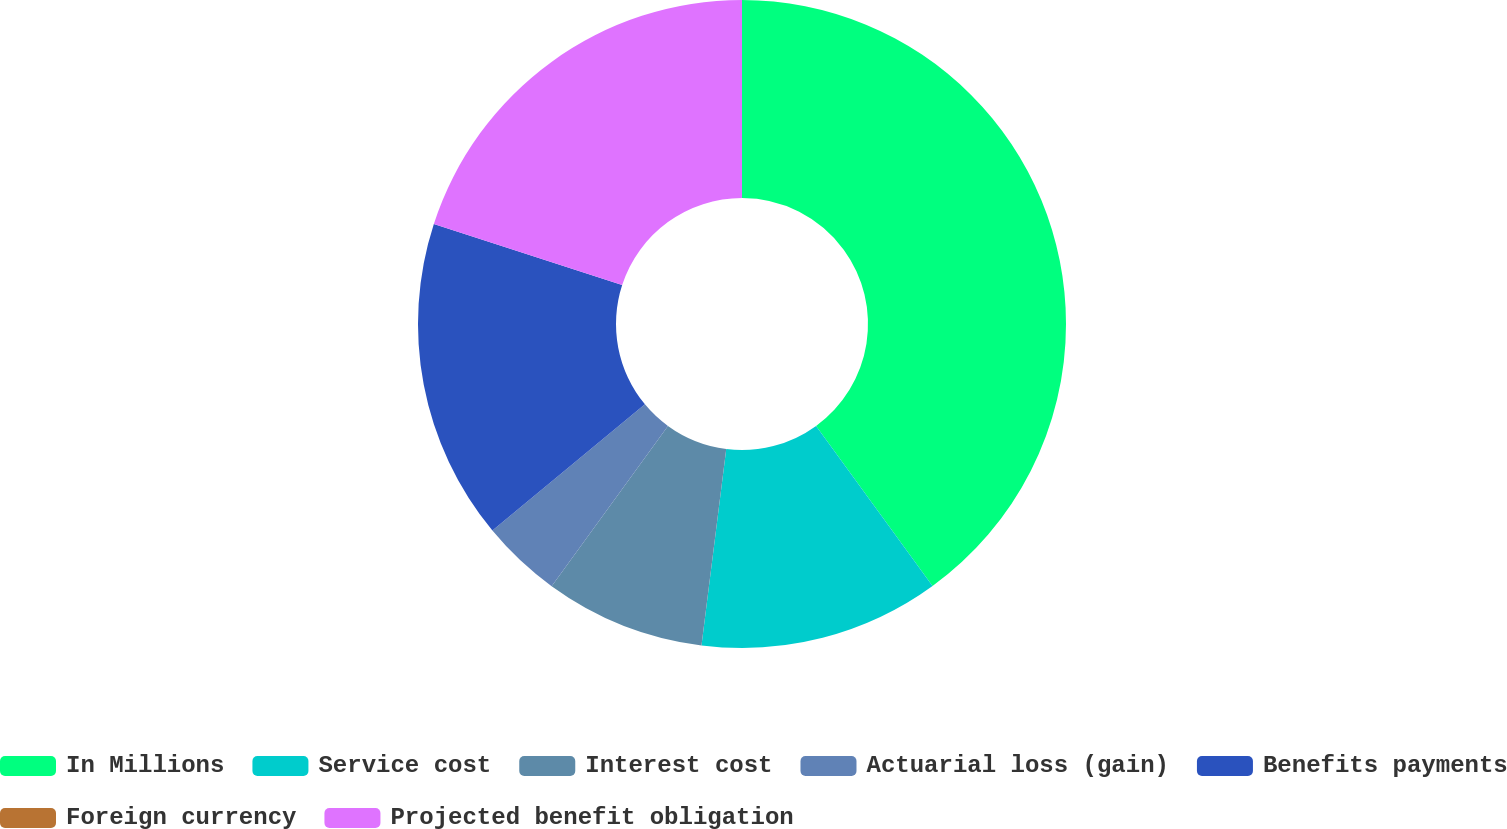Convert chart. <chart><loc_0><loc_0><loc_500><loc_500><pie_chart><fcel>In Millions<fcel>Service cost<fcel>Interest cost<fcel>Actuarial loss (gain)<fcel>Benefits payments<fcel>Foreign currency<fcel>Projected benefit obligation<nl><fcel>39.99%<fcel>12.0%<fcel>8.0%<fcel>4.0%<fcel>16.0%<fcel>0.0%<fcel>20.0%<nl></chart> 